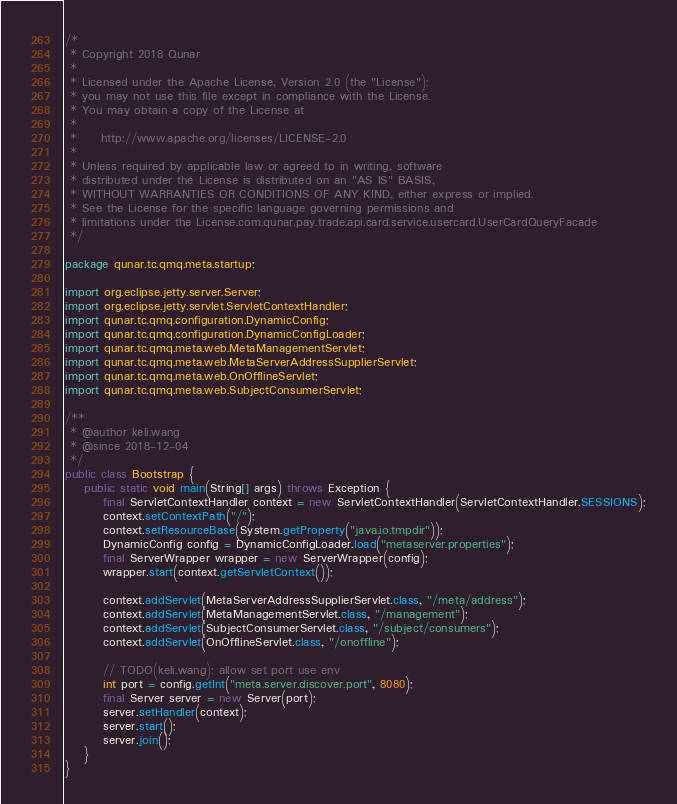Convert code to text. <code><loc_0><loc_0><loc_500><loc_500><_Java_>/*
 * Copyright 2018 Qunar
 *
 * Licensed under the Apache License, Version 2.0 (the "License");
 * you may not use this file except in compliance with the License.
 * You may obtain a copy of the License at
 *
 *     http://www.apache.org/licenses/LICENSE-2.0
 *
 * Unless required by applicable law or agreed to in writing, software
 * distributed under the License is distributed on an "AS IS" BASIS,
 * WITHOUT WARRANTIES OR CONDITIONS OF ANY KIND, either express or implied.
 * See the License for the specific language governing permissions and
 * limitations under the License.com.qunar.pay.trade.api.card.service.usercard.UserCardQueryFacade
 */

package qunar.tc.qmq.meta.startup;

import org.eclipse.jetty.server.Server;
import org.eclipse.jetty.servlet.ServletContextHandler;
import qunar.tc.qmq.configuration.DynamicConfig;
import qunar.tc.qmq.configuration.DynamicConfigLoader;
import qunar.tc.qmq.meta.web.MetaManagementServlet;
import qunar.tc.qmq.meta.web.MetaServerAddressSupplierServlet;
import qunar.tc.qmq.meta.web.OnOfflineServlet;
import qunar.tc.qmq.meta.web.SubjectConsumerServlet;

/**
 * @author keli.wang
 * @since 2018-12-04
 */
public class Bootstrap {
    public static void main(String[] args) throws Exception {
        final ServletContextHandler context = new ServletContextHandler(ServletContextHandler.SESSIONS);
        context.setContextPath("/");
        context.setResourceBase(System.getProperty("java.io.tmpdir"));
        DynamicConfig config = DynamicConfigLoader.load("metaserver.properties");
        final ServerWrapper wrapper = new ServerWrapper(config);
        wrapper.start(context.getServletContext());

        context.addServlet(MetaServerAddressSupplierServlet.class, "/meta/address");
        context.addServlet(MetaManagementServlet.class, "/management");
        context.addServlet(SubjectConsumerServlet.class, "/subject/consumers");
        context.addServlet(OnOfflineServlet.class, "/onoffline");

        // TODO(keli.wang): allow set port use env
        int port = config.getInt("meta.server.discover.port", 8080);
        final Server server = new Server(port);
        server.setHandler(context);
        server.start();
        server.join();
    }
}
</code> 